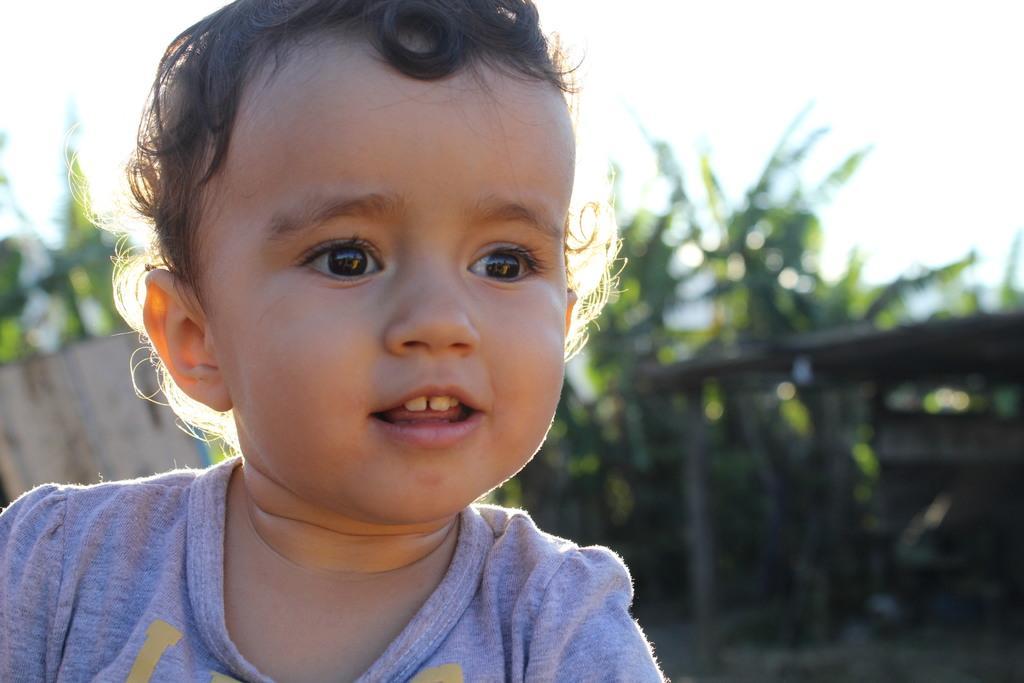In one or two sentences, can you explain what this image depicts? On the left side of this image there is a baby smiling. In the background there is a shed and few trees. At the top of the image I can see the sky. 